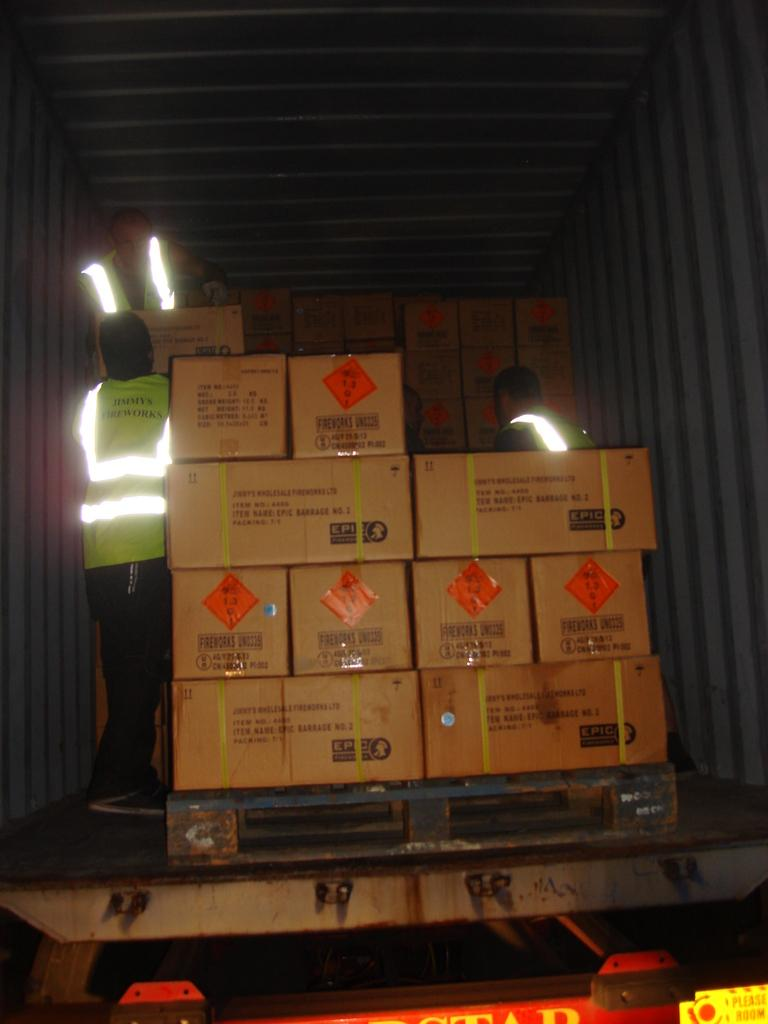How many people are in the image? There are three people in the image. What are the people wearing? The three people are wearing radium jackets. What else can be seen beside the people? There are cardboard boxes beside the people. What type of ear is visible on the people in the image? There is no specific ear mentioned or visible in the image; the focus is on the people wearing radium jackets and the presence of cardboard boxes. 